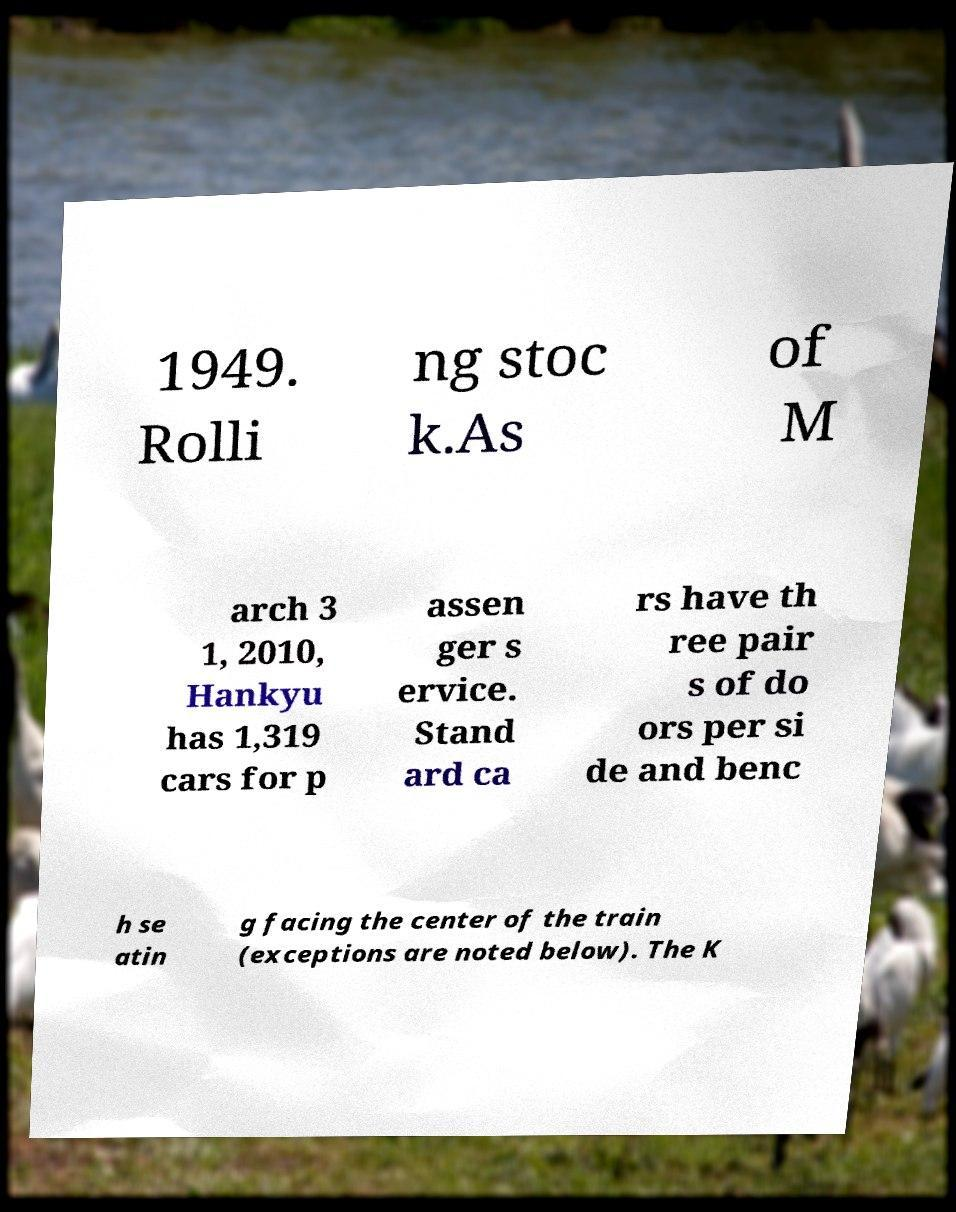I need the written content from this picture converted into text. Can you do that? 1949. Rolli ng stoc k.As of M arch 3 1, 2010, Hankyu has 1,319 cars for p assen ger s ervice. Stand ard ca rs have th ree pair s of do ors per si de and benc h se atin g facing the center of the train (exceptions are noted below). The K 